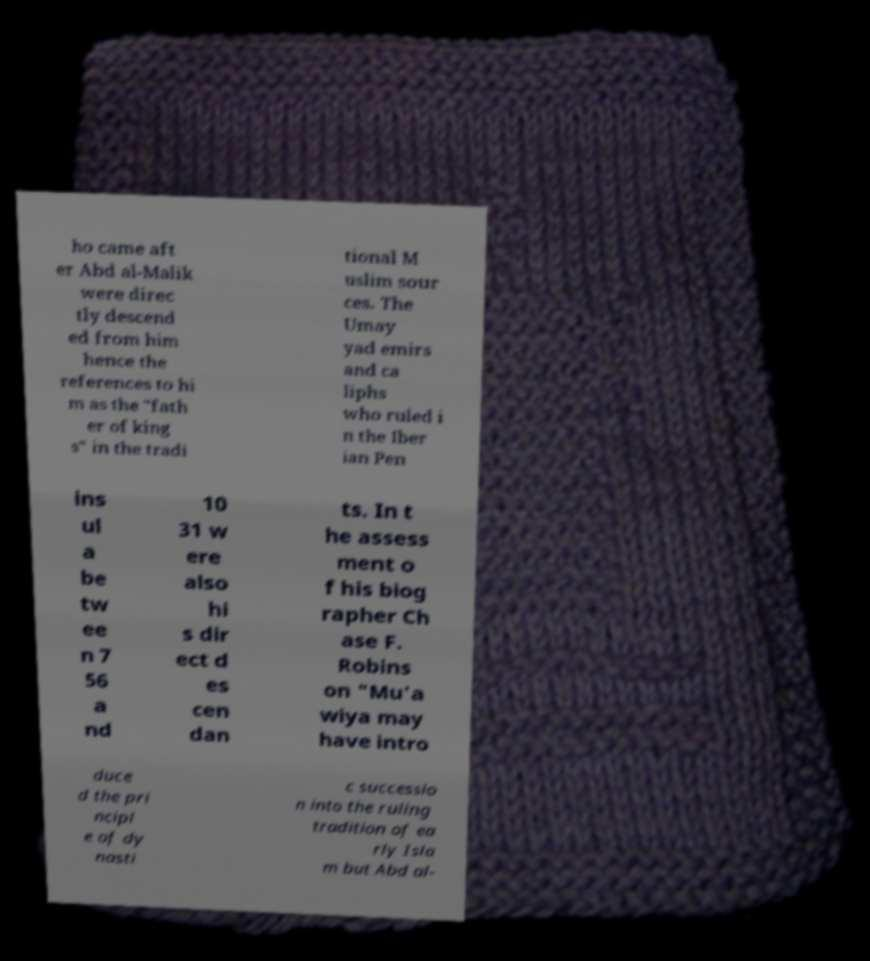What messages or text are displayed in this image? I need them in a readable, typed format. ho came aft er Abd al-Malik were direc tly descend ed from him hence the references to hi m as the "fath er of king s" in the tradi tional M uslim sour ces. The Umay yad emirs and ca liphs who ruled i n the Iber ian Pen ins ul a be tw ee n 7 56 a nd 10 31 w ere also hi s dir ect d es cen dan ts. In t he assess ment o f his biog rapher Ch ase F. Robins on "Mu'a wiya may have intro duce d the pri ncipl e of dy nasti c successio n into the ruling tradition of ea rly Isla m but Abd al- 